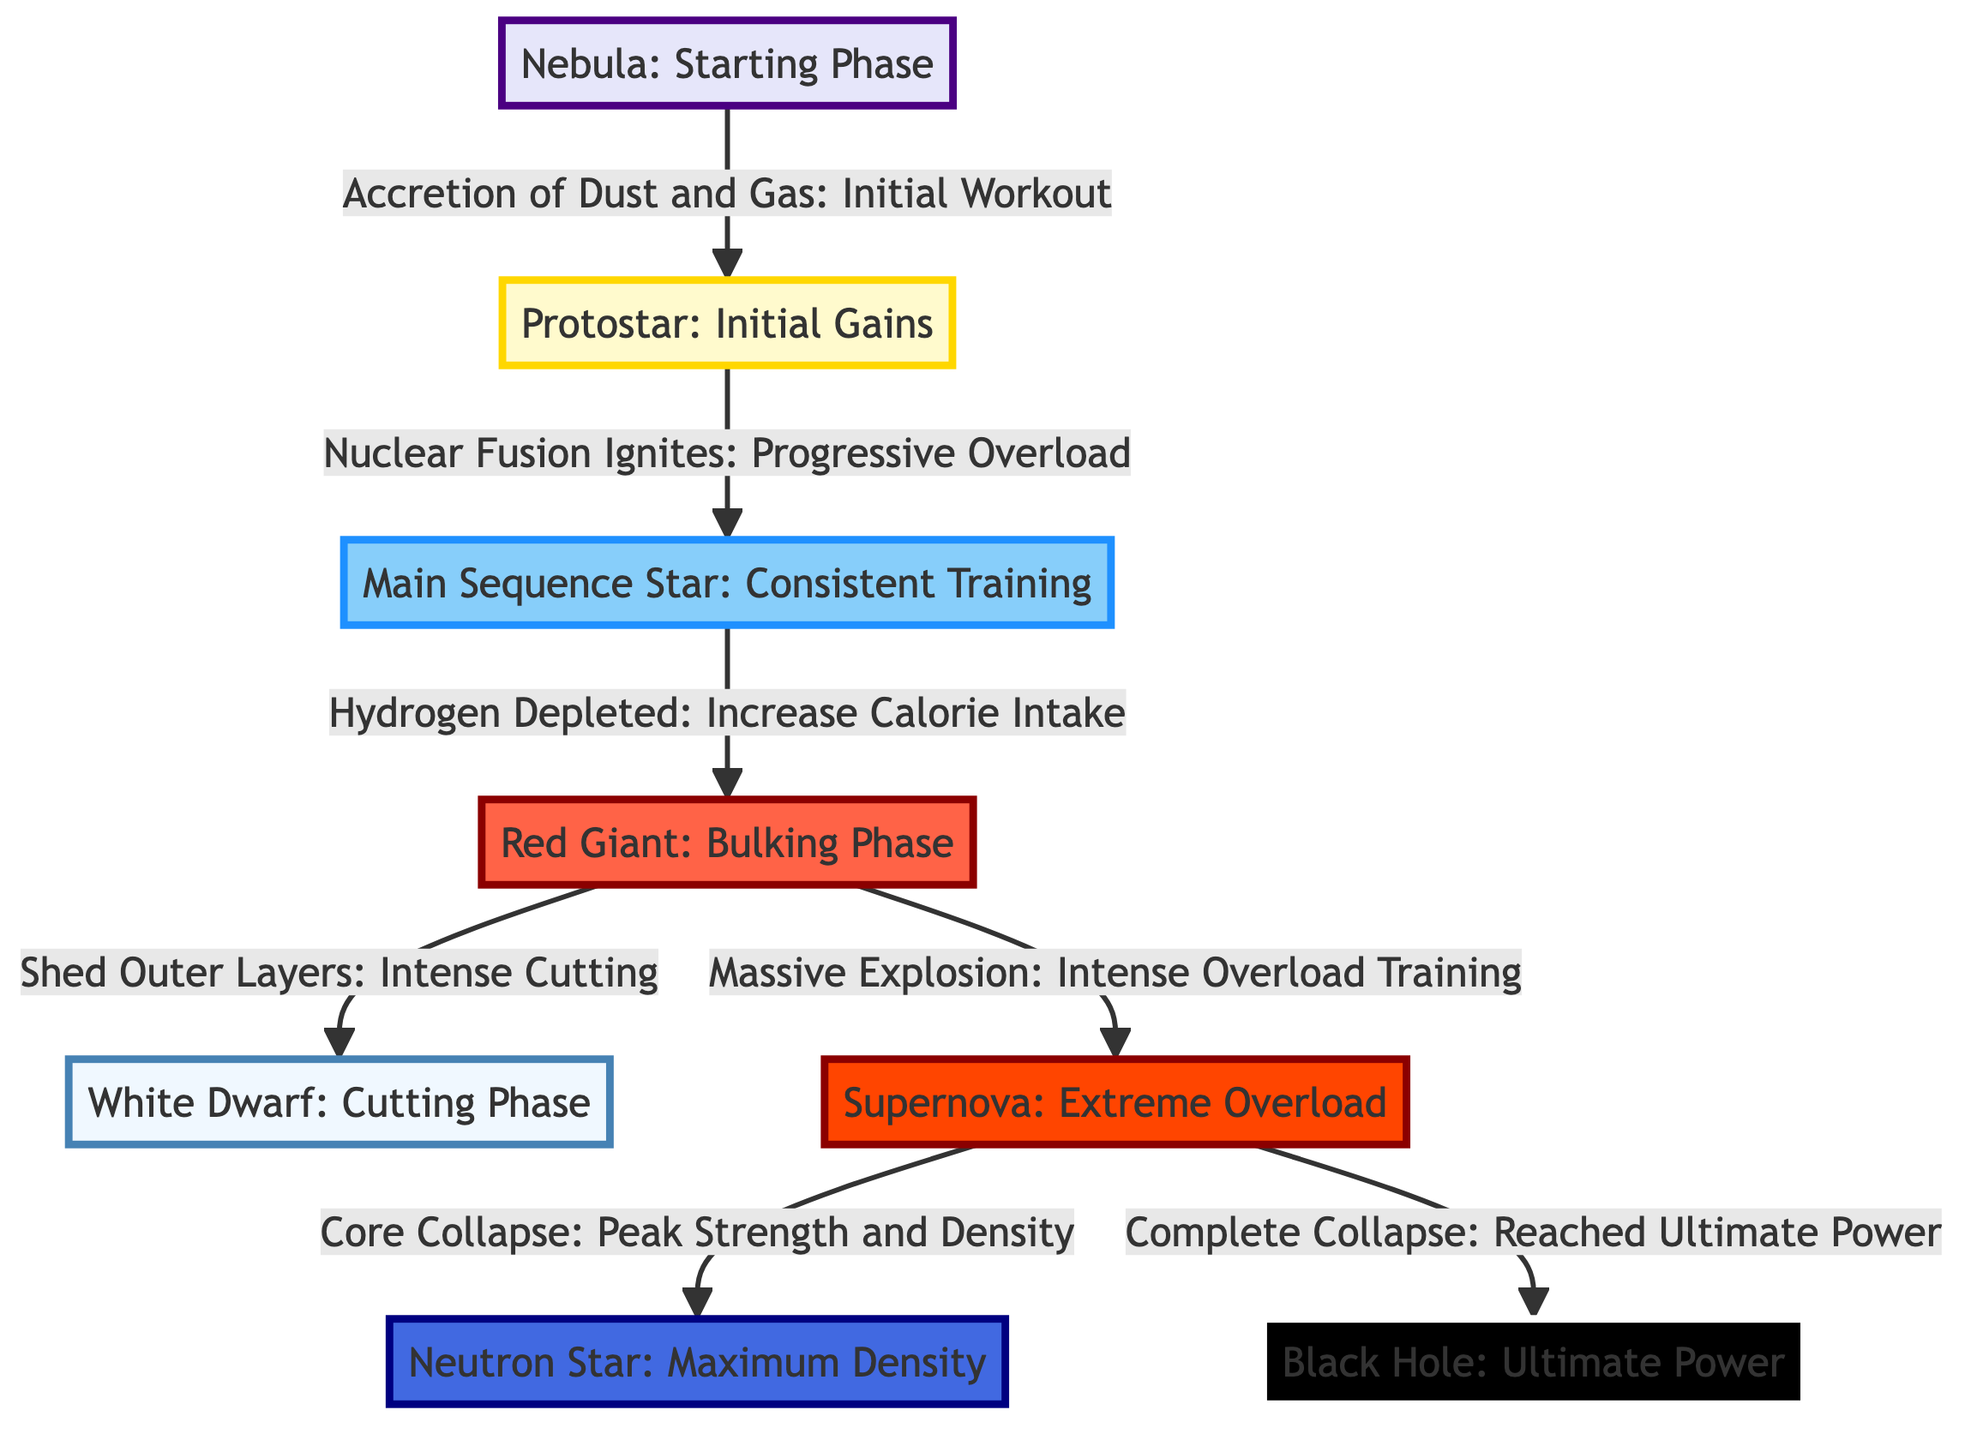What is the starting phase of the star life cycle? The diagram clearly labels the first stage as "Nebula: Starting Phase," indicating this is where the star life cycle begins.
Answer: Nebula: Starting Phase What comes after the Protostar stage? From the diagram, the directional arrow leading from "Protostar" points to "Main Sequence Star," indicating this is the next stage in the life cycle.
Answer: Main Sequence Star How many main stages are outlined in the diagram? By counting the nodes in the flowchart, we can identify eight key stages represented, including the different phases of a star’s life cycle.
Answer: Eight During which stage does nuclear fusion ignite? The diagram specifically indicates that "Nuclear Fusion Ignites" occurs during the transition from "Protostar" to "Main Sequence Star."
Answer: Main Sequence Star What analogy is used for the Red Giant phase? The flowchart describes the "Red Giant: Bulking Phase," suggesting that this phase correlates to muscle hypertrophy or bulking in a bodybuilder's training.
Answer: Bulking Phase What happens to a star once it has depleted its hydrogen? The diagram shows that after "Hydrogen Depleted," the star transitions into the "Red Giant: Increase Calorie Intake" stage, indicating a phase of increased resource consumption or bulking.
Answer: Increase Calorie Intake Which phase represents the ultimate power in the star life cycle? The diagram labels the last stage as "Black Hole: Ultimate Power," highlighting it as the funneling point where the star reaches its maximum density and influence.
Answer: Ultimate Power What event corresponds to the Supernova phase? In the diagram, the "Supernova: Extreme Overload" indicates that this phase involves a massive explosion that can be interpreted as the culmination of excess effort or overload training in bodybuilding.
Answer: Extreme Overload Which stage is characterized by intense cutting? The flowchart indicates that the "White Dwarf: Cutting Phase" is where the star sheds outer layers, analogous to a cutting diet in bodybuilding aimed at reducing body fat.
Answer: Cutting Phase 